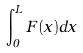Convert formula to latex. <formula><loc_0><loc_0><loc_500><loc_500>\int _ { 0 } ^ { L } F ( x ) d x</formula> 